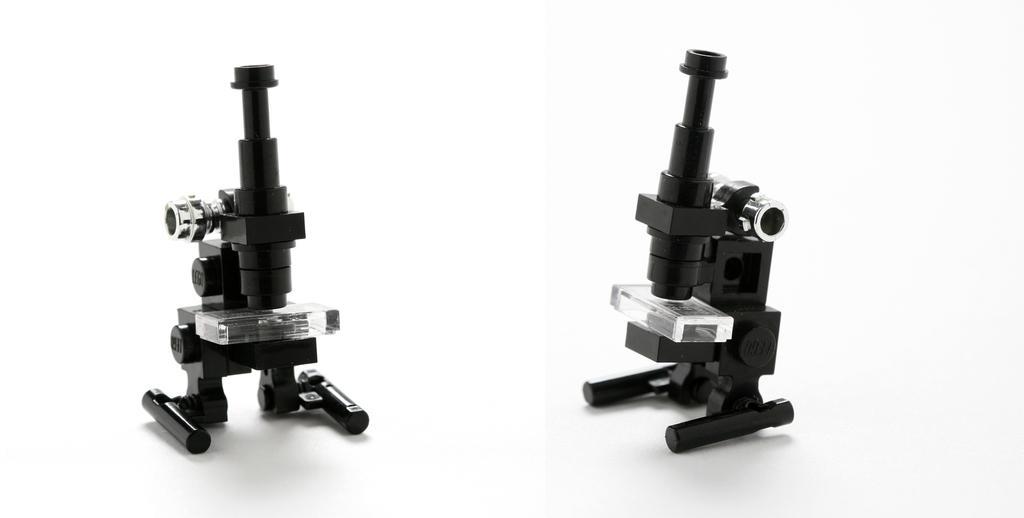Please provide a concise description of this image. In this image we can see microscopes. In the background it is white. 